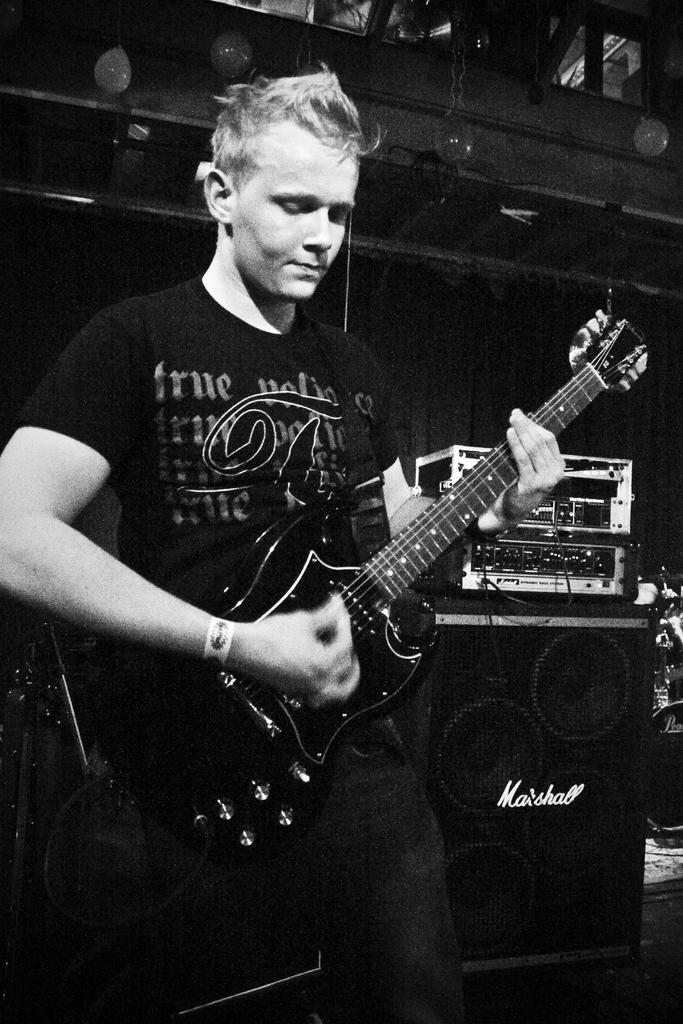Could you give a brief overview of what you see in this image? This picture shows a man holding a guitar in his hands and playing it. In the background there is speaker and music equipment hire. 